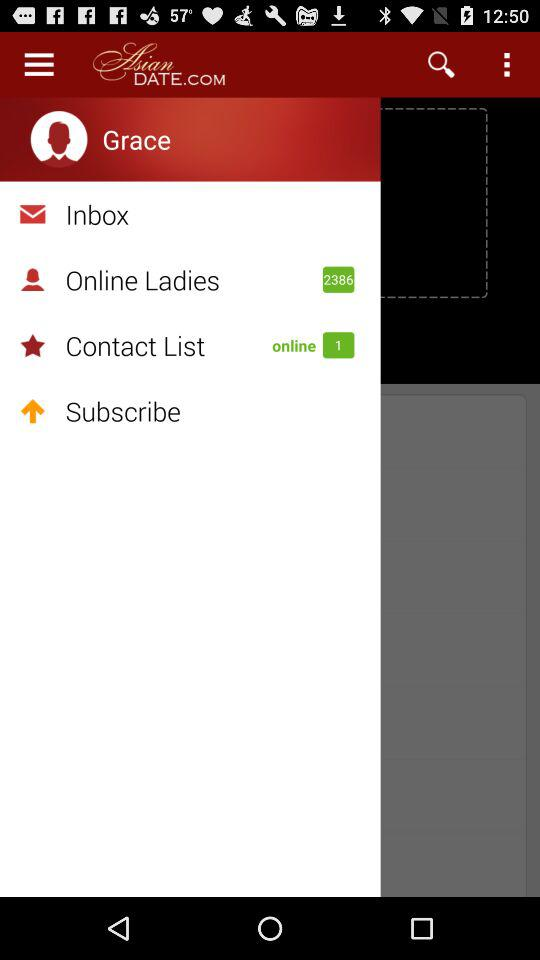What is the name of the application? The name of the application is "Asian DATE.COM". 